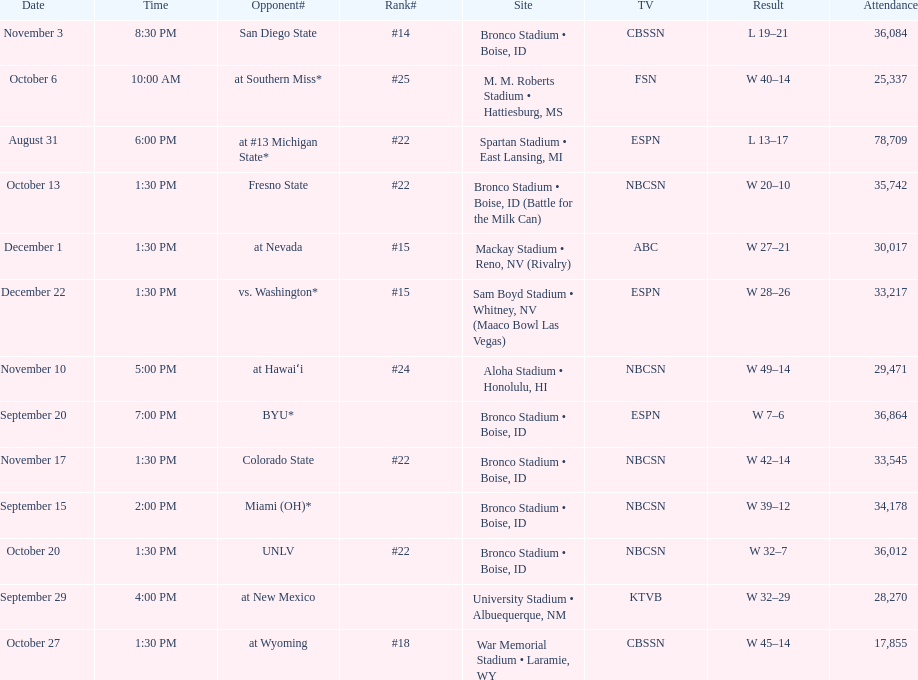Could you parse the entire table as a dict? {'header': ['Date', 'Time', 'Opponent#', 'Rank#', 'Site', 'TV', 'Result', 'Attendance'], 'rows': [['November 3', '8:30 PM', 'San Diego State', '#14', 'Bronco Stadium • Boise, ID', 'CBSSN', 'L\xa019–21', '36,084'], ['October 6', '10:00 AM', 'at\xa0Southern Miss*', '#25', 'M. M. Roberts Stadium • Hattiesburg, MS', 'FSN', 'W\xa040–14', '25,337'], ['August 31', '6:00 PM', 'at\xa0#13\xa0Michigan State*', '#22', 'Spartan Stadium • East Lansing, MI', 'ESPN', 'L\xa013–17', '78,709'], ['October 13', '1:30 PM', 'Fresno State', '#22', 'Bronco Stadium • Boise, ID (Battle for the Milk Can)', 'NBCSN', 'W\xa020–10', '35,742'], ['December 1', '1:30 PM', 'at\xa0Nevada', '#15', 'Mackay Stadium • Reno, NV (Rivalry)', 'ABC', 'W\xa027–21', '30,017'], ['December 22', '1:30 PM', 'vs.\xa0Washington*', '#15', 'Sam Boyd Stadium • Whitney, NV (Maaco Bowl Las Vegas)', 'ESPN', 'W\xa028–26', '33,217'], ['November 10', '5:00 PM', 'at\xa0Hawaiʻi', '#24', 'Aloha Stadium • Honolulu, HI', 'NBCSN', 'W\xa049–14', '29,471'], ['September 20', '7:00 PM', 'BYU*', '', 'Bronco Stadium • Boise, ID', 'ESPN', 'W\xa07–6', '36,864'], ['November 17', '1:30 PM', 'Colorado State', '#22', 'Bronco Stadium • Boise, ID', 'NBCSN', 'W\xa042–14', '33,545'], ['September 15', '2:00 PM', 'Miami (OH)*', '', 'Bronco Stadium • Boise, ID', 'NBCSN', 'W\xa039–12', '34,178'], ['October 20', '1:30 PM', 'UNLV', '#22', 'Bronco Stadium • Boise, ID', 'NBCSN', 'W\xa032–7', '36,012'], ['September 29', '4:00 PM', 'at\xa0New Mexico', '', 'University Stadium • Albuequerque, NM', 'KTVB', 'W\xa032–29', '28,270'], ['October 27', '1:30 PM', 'at\xa0Wyoming', '#18', 'War Memorial Stadium • Laramie, WY', 'CBSSN', 'W\xa045–14', '17,855']]} What was the most consecutive wins for the team shown in the season? 7. 